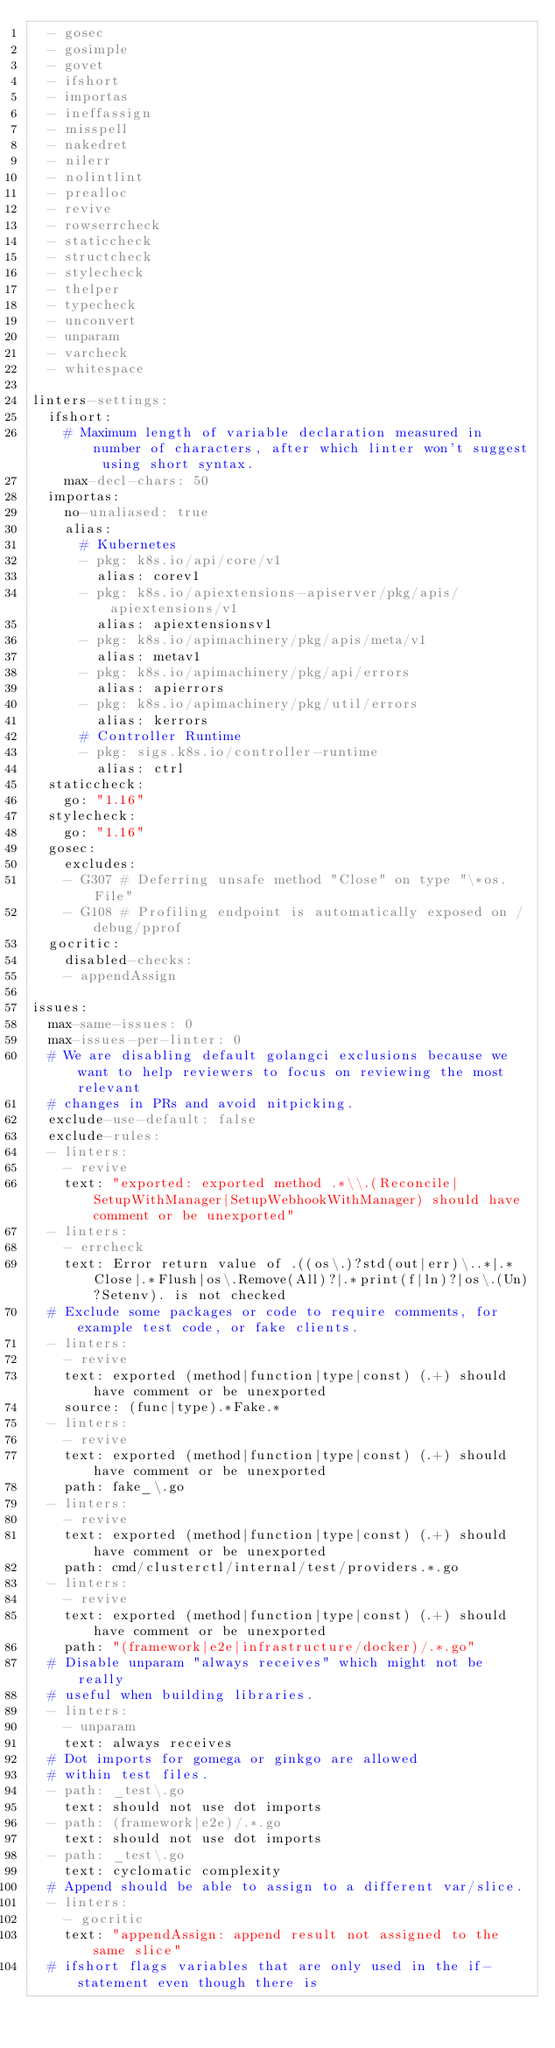<code> <loc_0><loc_0><loc_500><loc_500><_YAML_>  - gosec
  - gosimple
  - govet
  - ifshort
  - importas
  - ineffassign
  - misspell
  - nakedret
  - nilerr
  - nolintlint
  - prealloc
  - revive
  - rowserrcheck
  - staticcheck
  - structcheck
  - stylecheck
  - thelper
  - typecheck
  - unconvert
  - unparam
  - varcheck
  - whitespace

linters-settings:
  ifshort:
    # Maximum length of variable declaration measured in number of characters, after which linter won't suggest using short syntax.
    max-decl-chars: 50
  importas:
    no-unaliased: true
    alias:
      # Kubernetes
      - pkg: k8s.io/api/core/v1
        alias: corev1
      - pkg: k8s.io/apiextensions-apiserver/pkg/apis/apiextensions/v1
        alias: apiextensionsv1
      - pkg: k8s.io/apimachinery/pkg/apis/meta/v1
        alias: metav1
      - pkg: k8s.io/apimachinery/pkg/api/errors
        alias: apierrors
      - pkg: k8s.io/apimachinery/pkg/util/errors
        alias: kerrors
      # Controller Runtime
      - pkg: sigs.k8s.io/controller-runtime
        alias: ctrl
  staticcheck:
    go: "1.16"
  stylecheck:
    go: "1.16"
  gosec:
    excludes:
    - G307 # Deferring unsafe method "Close" on type "\*os.File"
    - G108 # Profiling endpoint is automatically exposed on /debug/pprof
  gocritic:
    disabled-checks:
    - appendAssign

issues:
  max-same-issues: 0
  max-issues-per-linter: 0
  # We are disabling default golangci exclusions because we want to help reviewers to focus on reviewing the most relevant
  # changes in PRs and avoid nitpicking.
  exclude-use-default: false
  exclude-rules:
  - linters:
    - revive
    text: "exported: exported method .*\\.(Reconcile|SetupWithManager|SetupWebhookWithManager) should have comment or be unexported"
  - linters:
    - errcheck
    text: Error return value of .((os\.)?std(out|err)\..*|.*Close|.*Flush|os\.Remove(All)?|.*print(f|ln)?|os\.(Un)?Setenv). is not checked
  # Exclude some packages or code to require comments, for example test code, or fake clients.
  - linters:
    - revive
    text: exported (method|function|type|const) (.+) should have comment or be unexported
    source: (func|type).*Fake.*
  - linters:
    - revive
    text: exported (method|function|type|const) (.+) should have comment or be unexported
    path: fake_\.go
  - linters:
    - revive
    text: exported (method|function|type|const) (.+) should have comment or be unexported
    path: cmd/clusterctl/internal/test/providers.*.go
  - linters:
    - revive
    text: exported (method|function|type|const) (.+) should have comment or be unexported
    path: "(framework|e2e|infrastructure/docker)/.*.go"
  # Disable unparam "always receives" which might not be really
  # useful when building libraries.
  - linters:
    - unparam
    text: always receives
  # Dot imports for gomega or ginkgo are allowed
  # within test files.
  - path: _test\.go
    text: should not use dot imports
  - path: (framework|e2e)/.*.go
    text: should not use dot imports
  - path: _test\.go
    text: cyclomatic complexity
  # Append should be able to assign to a different var/slice.
  - linters:
    - gocritic
    text: "appendAssign: append result not assigned to the same slice"
  # ifshort flags variables that are only used in the if-statement even though there is</code> 